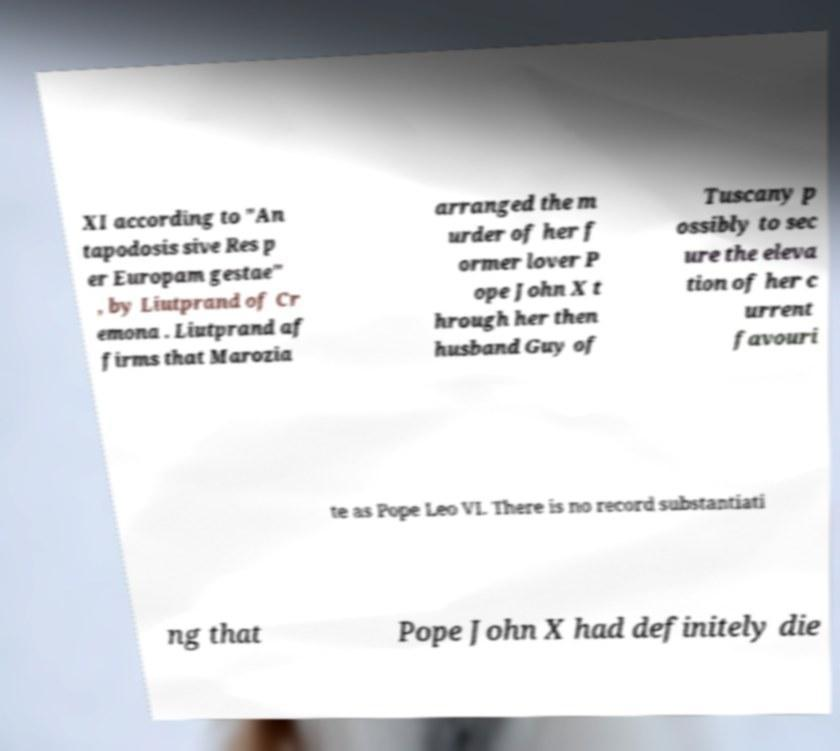Please read and relay the text visible in this image. What does it say? XI according to "An tapodosis sive Res p er Europam gestae" , by Liutprand of Cr emona . Liutprand af firms that Marozia arranged the m urder of her f ormer lover P ope John X t hrough her then husband Guy of Tuscany p ossibly to sec ure the eleva tion of her c urrent favouri te as Pope Leo VI. There is no record substantiati ng that Pope John X had definitely die 